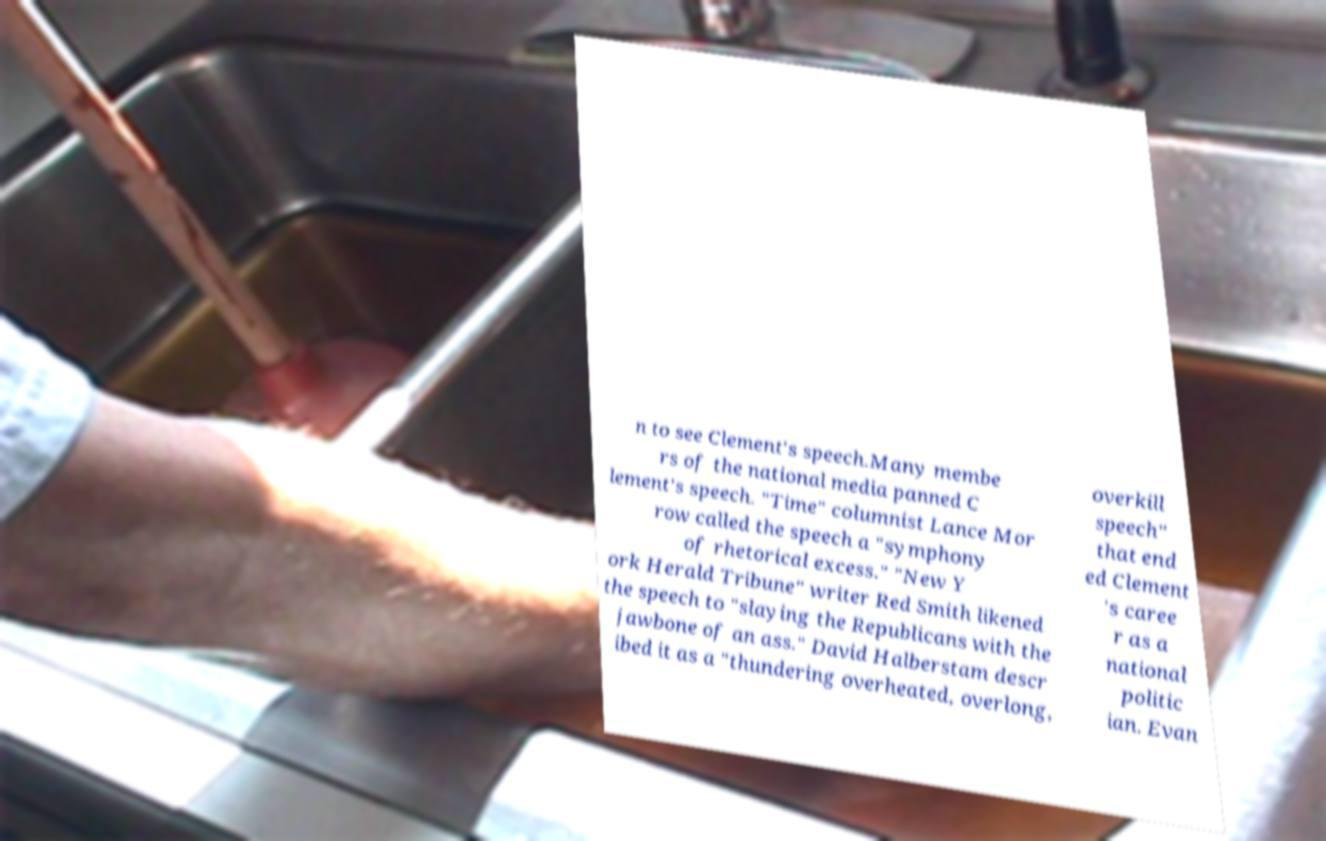Please read and relay the text visible in this image. What does it say? n to see Clement's speech.Many membe rs of the national media panned C lement's speech. "Time" columnist Lance Mor row called the speech a "symphony of rhetorical excess." "New Y ork Herald Tribune" writer Red Smith likened the speech to "slaying the Republicans with the jawbone of an ass." David Halberstam descr ibed it as a "thundering overheated, overlong, overkill speech" that end ed Clement 's caree r as a national politic ian. Evan 